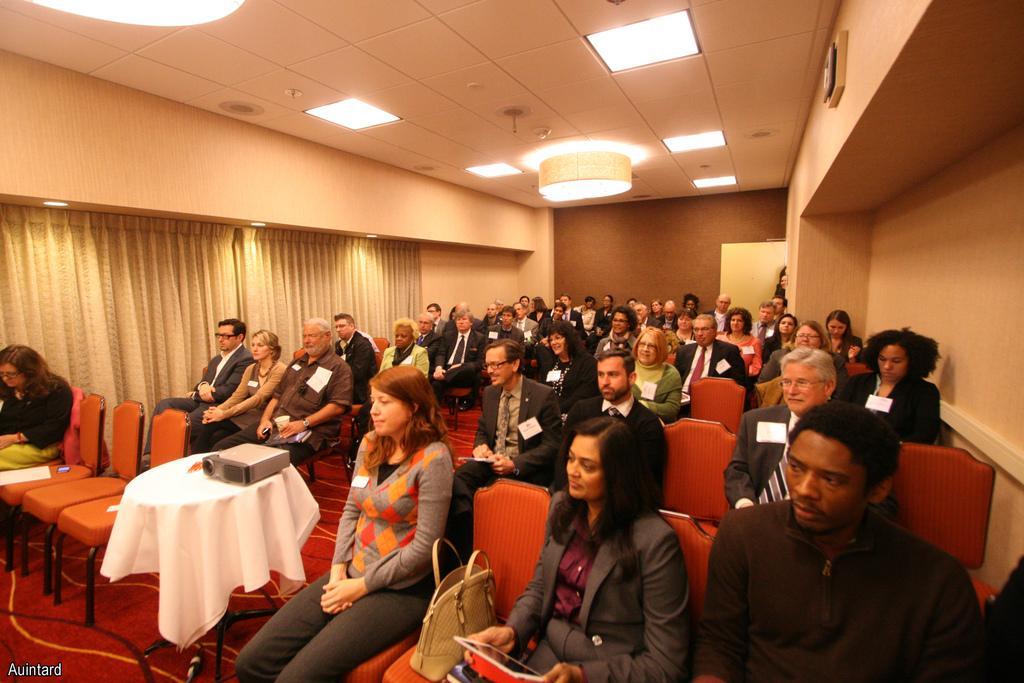Describe this image in one or two sentences. In this picture we can see a room where we have a group of people sitting on the chairs wearing some batches and there is a table between them on which there is a projector and some lights on the roof. 